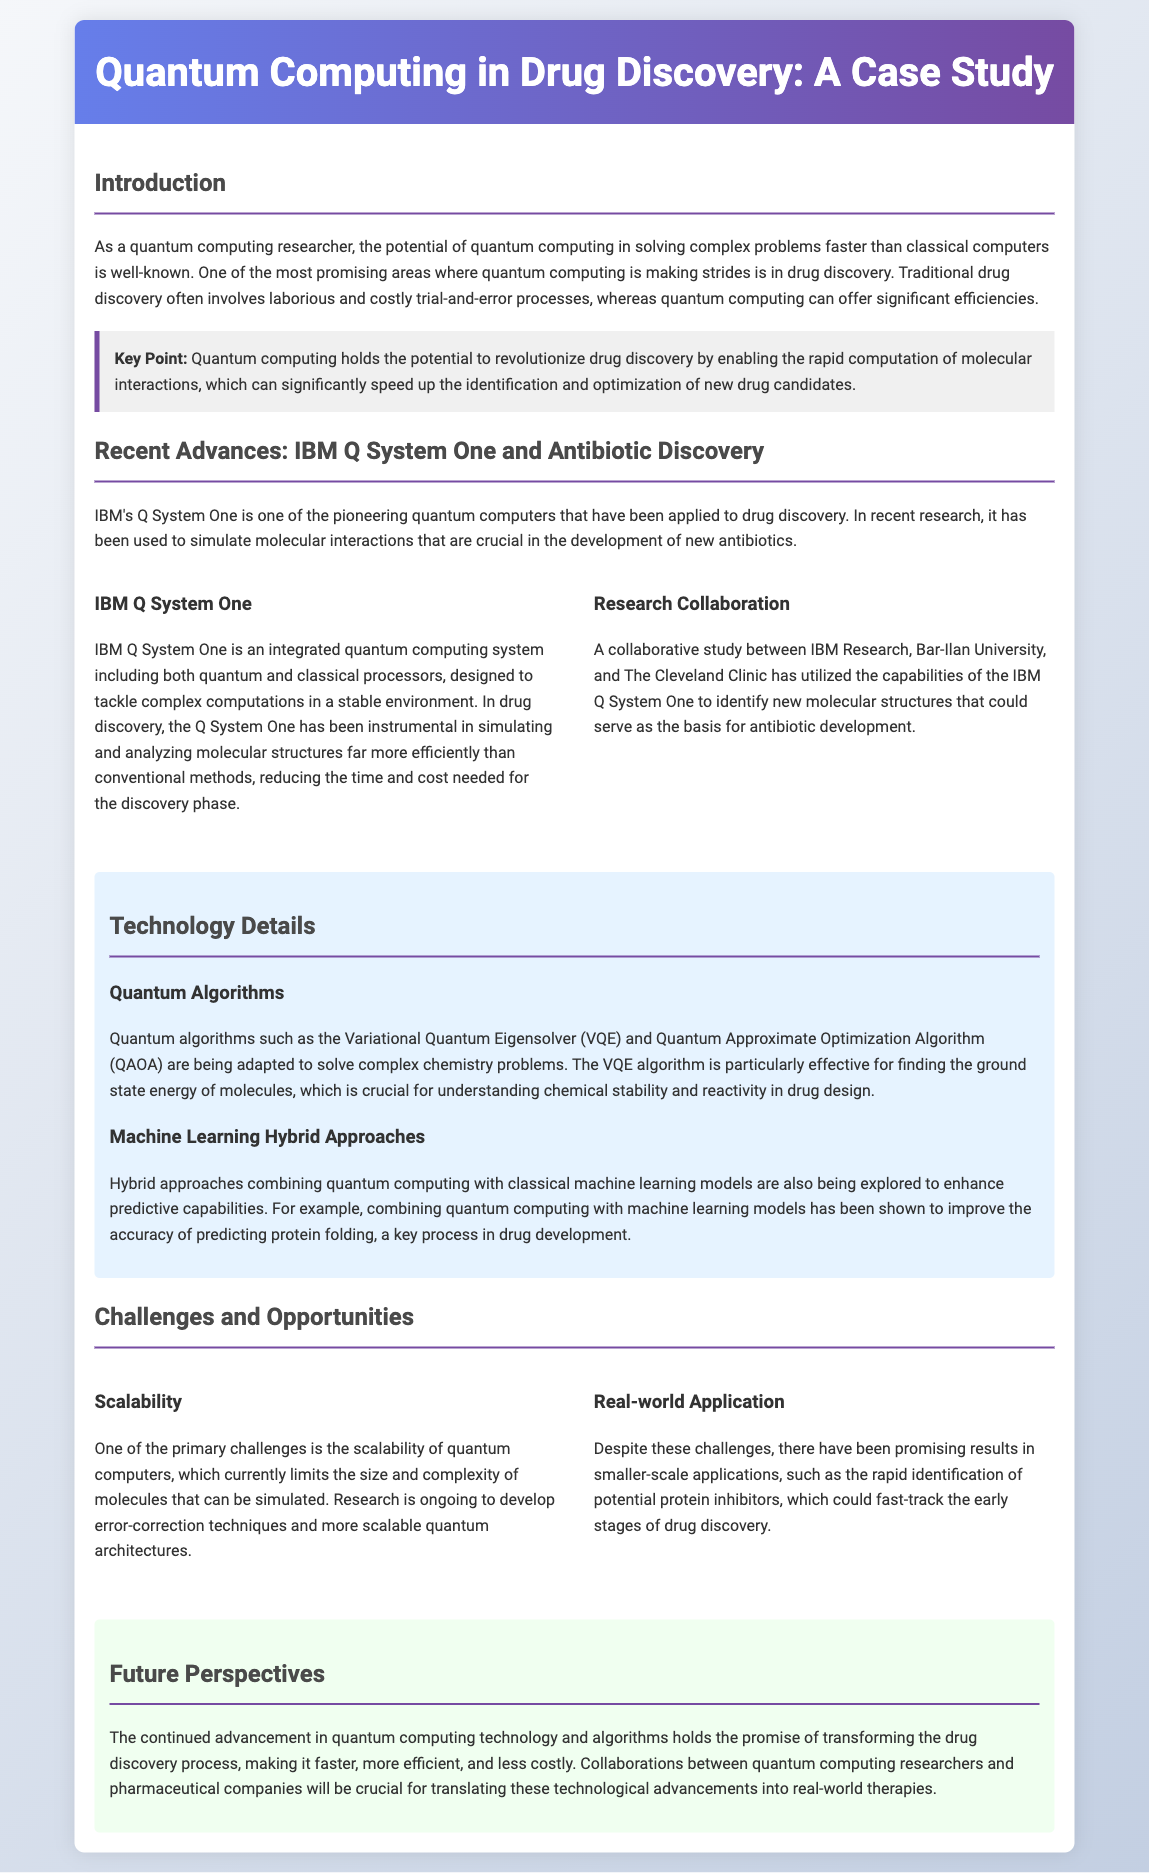What is the potential of quantum computing in drug discovery? The document states that quantum computing holds the potential to revolutionize drug discovery by enabling the rapid computation of molecular interactions.
Answer: Revolutionize drug discovery What is the name of the quantum computer mentioned in the case study? The document mentions IBM's Q System One as the pioneering quantum computer applied to drug discovery.
Answer: IBM Q System One What collaborative institutions are involved in the research using IBM Q System One? The document lists IBM Research, Bar-Ilan University, and The Cleveland Clinic as collaborating institutions.
Answer: IBM Research, Bar-Ilan University, The Cleveland Clinic What quantum algorithm is particularly effective for finding ground state energy? The document mentions the Variational Quantum Eigensolver (VQE) as the effective algorithm for this purpose.
Answer: Variational Quantum Eigensolver (VQE) What is a key challenge mentioned for quantum computers in drug discovery? The document states that one of the primary challenges is the scalability of quantum computers.
Answer: Scalability How does the document describe the future of quantum computing technology in drug discovery? It is stated that the advancement in quantum computing technology holds the promise of transforming the drug discovery process.
Answer: Transforming the drug discovery process Which hybrid approaches are being explored to enhance predictive capabilities? The document notes that hybrid approaches combining quantum computing with classical machine learning models are being explored.
Answer: Quantum computing and classical machine learning What significant outcome has been achieved despite the challenges in quantum computing? The document notes promising results in smaller-scale applications, such as rapid identification of potential protein inhibitors.
Answer: Rapid identification of potential protein inhibitors 